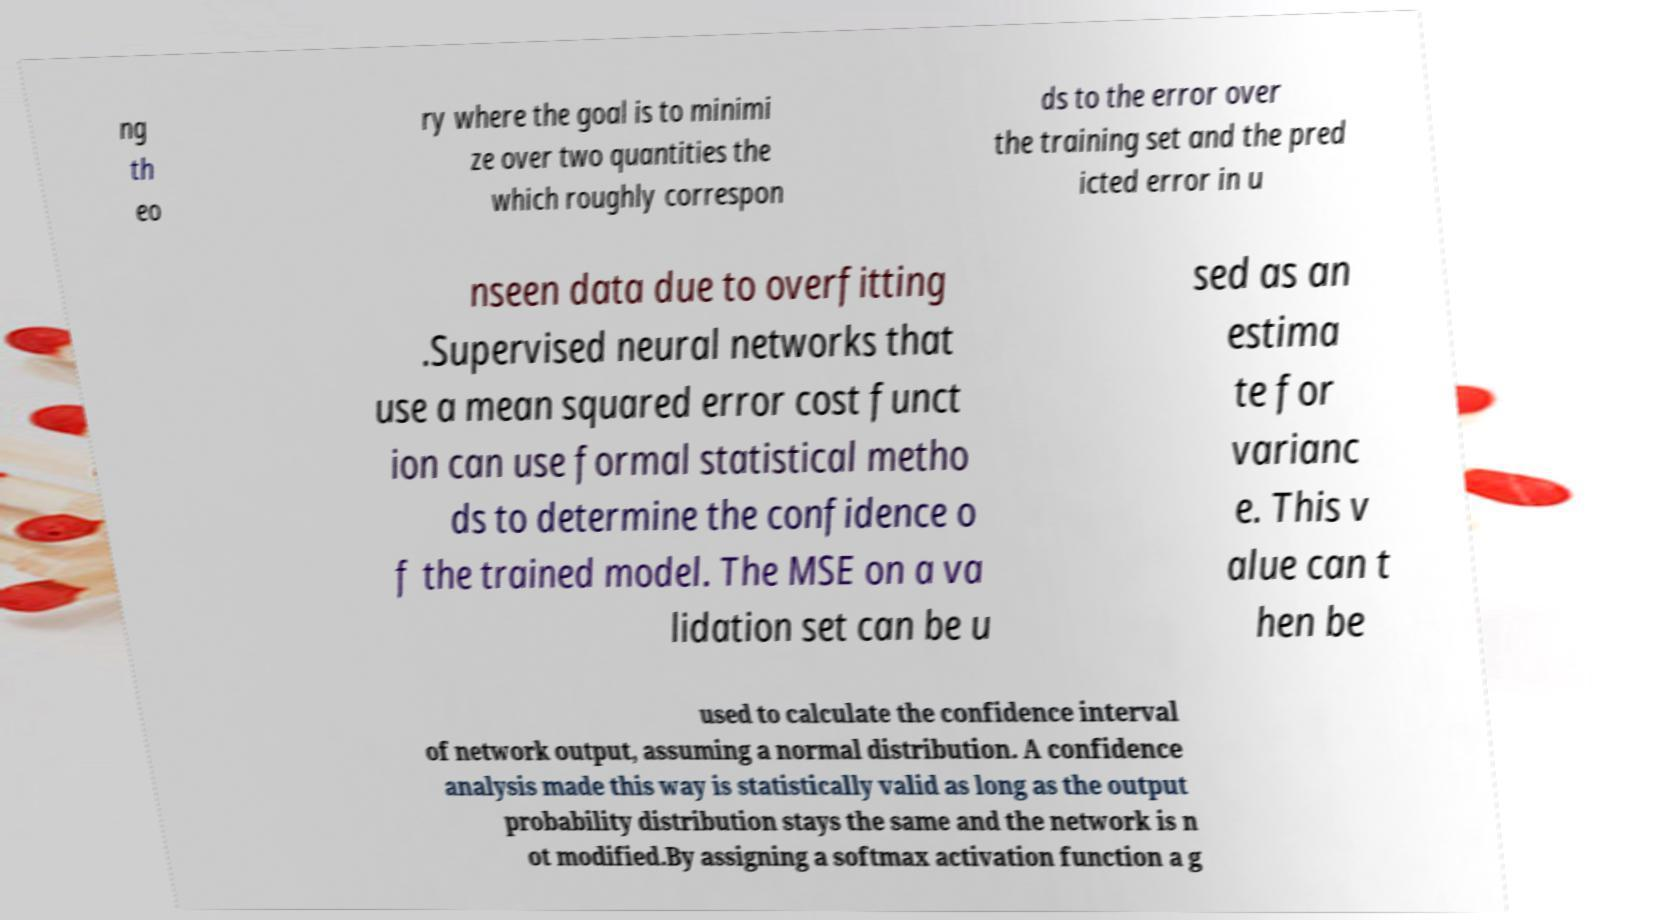Could you extract and type out the text from this image? ng th eo ry where the goal is to minimi ze over two quantities the which roughly correspon ds to the error over the training set and the pred icted error in u nseen data due to overfitting .Supervised neural networks that use a mean squared error cost funct ion can use formal statistical metho ds to determine the confidence o f the trained model. The MSE on a va lidation set can be u sed as an estima te for varianc e. This v alue can t hen be used to calculate the confidence interval of network output, assuming a normal distribution. A confidence analysis made this way is statistically valid as long as the output probability distribution stays the same and the network is n ot modified.By assigning a softmax activation function a g 